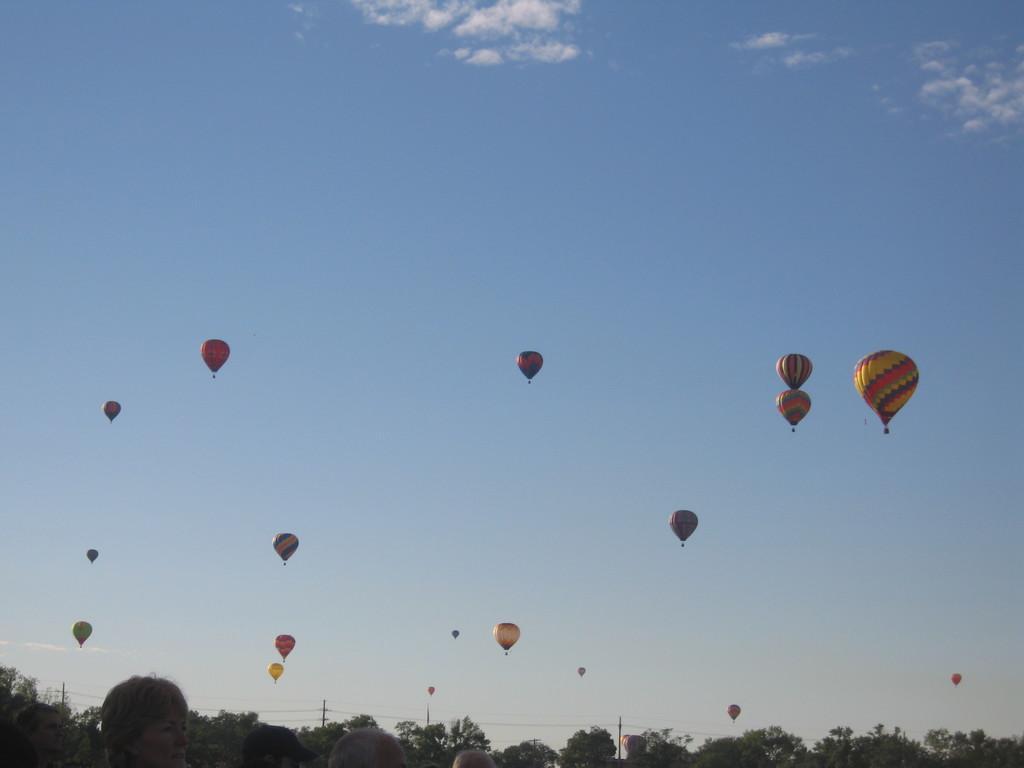Please provide a concise description of this image. In this picture we can see a group of people, trees, poles, wires and a group of parachutes flying in the sky. 